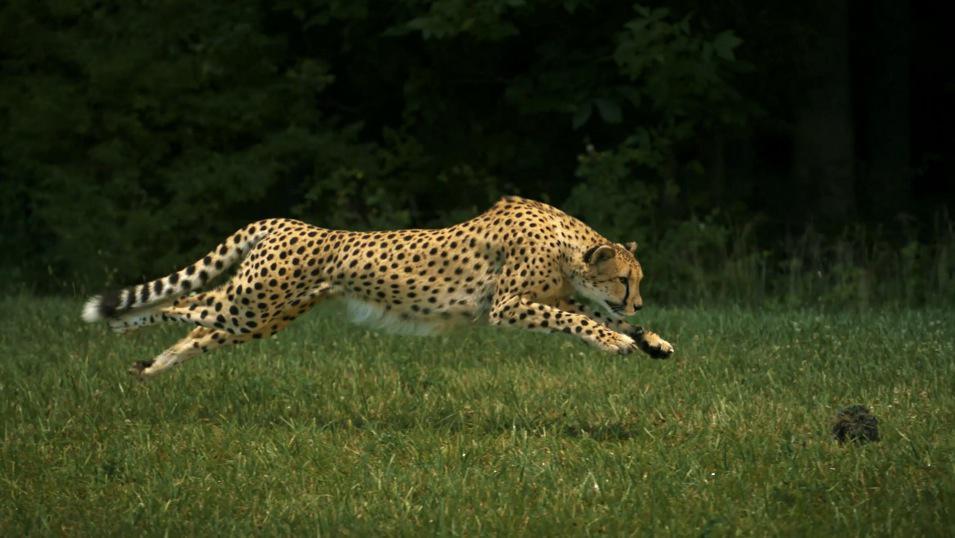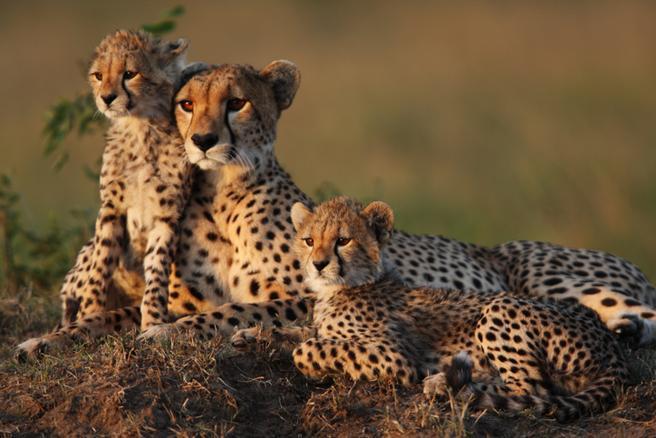The first image is the image on the left, the second image is the image on the right. Given the left and right images, does the statement "There is a mother cheetah sitting and watching as her 3 cubs are close to her" hold true? Answer yes or no. No. The first image is the image on the left, the second image is the image on the right. Given the left and right images, does the statement "A single cheetah is leaping in the air in the left image." hold true? Answer yes or no. Yes. 